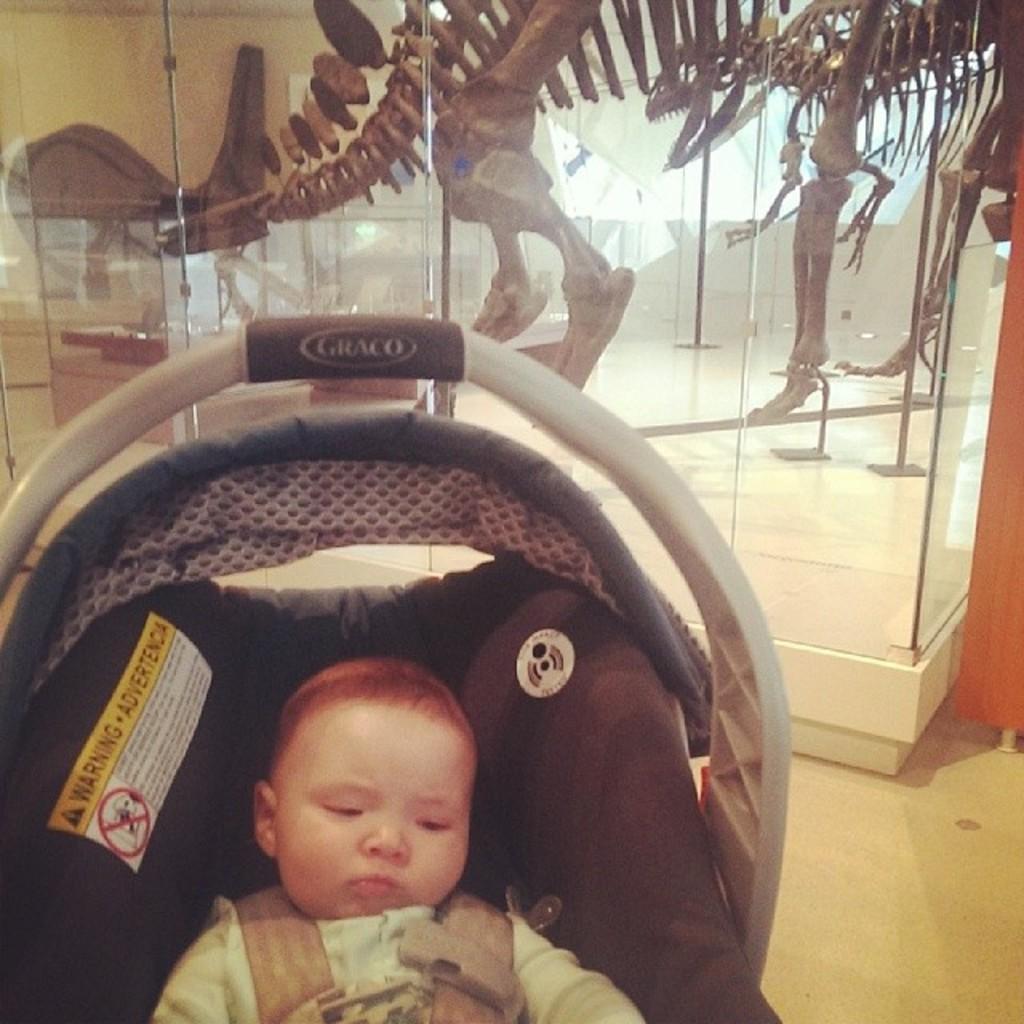In one or two sentences, can you explain what this image depicts? In this image there is a person and there is an object in the foreground. There is a wooden object on the right corner. There is a glass in which we can see a skeleton of an animal in the background. 